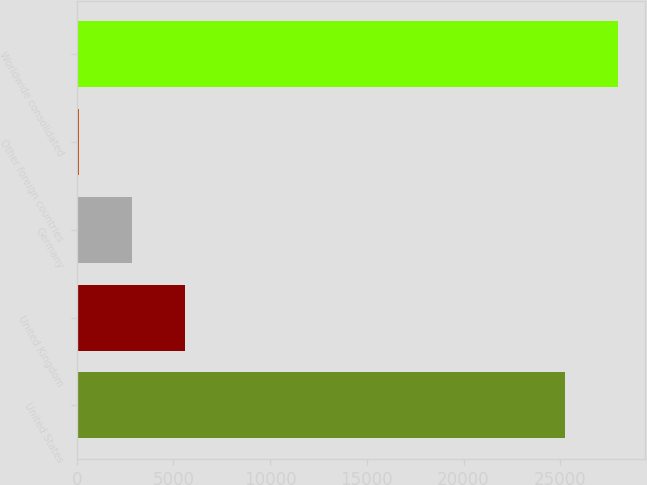Convert chart. <chart><loc_0><loc_0><loc_500><loc_500><bar_chart><fcel>United States<fcel>United Kingdom<fcel>Germany<fcel>Other foreign countries<fcel>Worldwide consolidated<nl><fcel>25255<fcel>5577.6<fcel>2851.8<fcel>126<fcel>27980.8<nl></chart> 